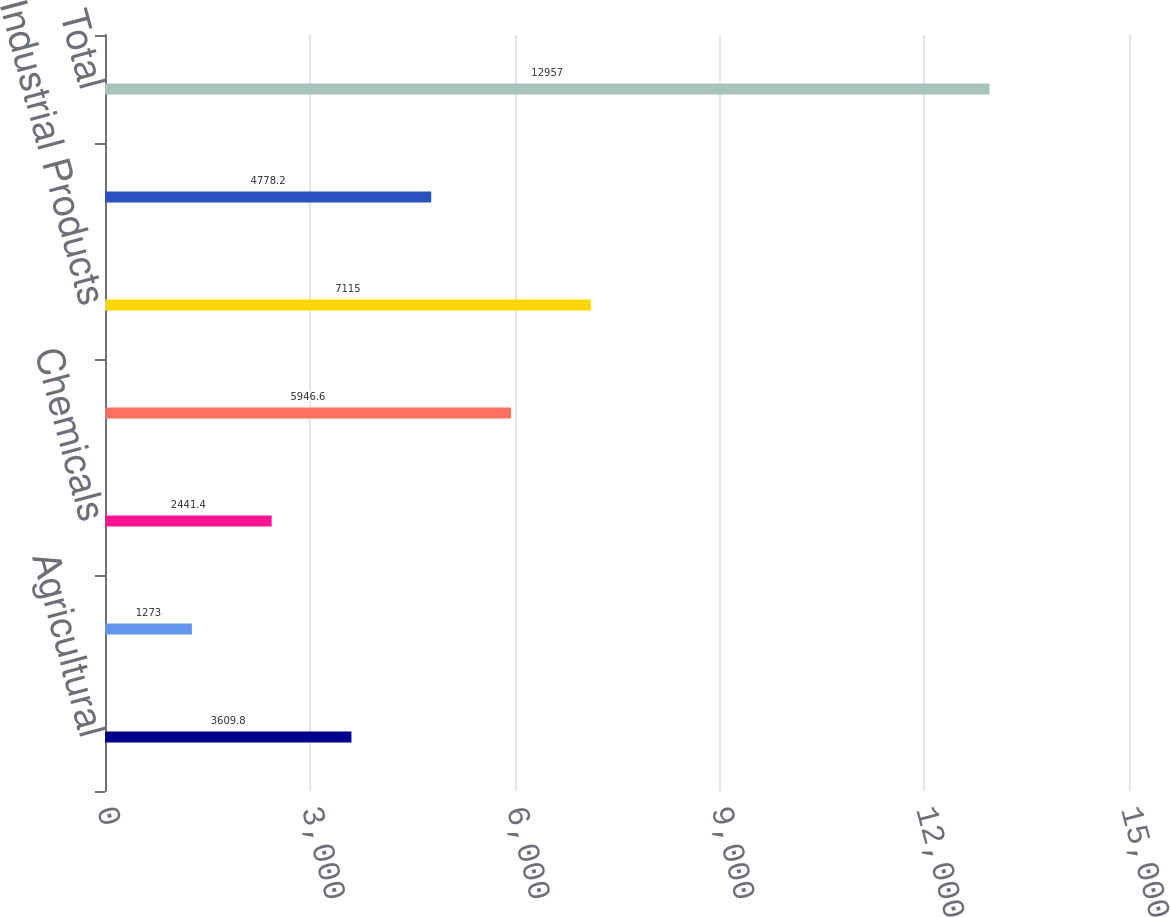<chart> <loc_0><loc_0><loc_500><loc_500><bar_chart><fcel>Agricultural<fcel>Automotive<fcel>Chemicals<fcel>Energy<fcel>Industrial Products<fcel>Intermodal<fcel>Total<nl><fcel>3609.8<fcel>1273<fcel>2441.4<fcel>5946.6<fcel>7115<fcel>4778.2<fcel>12957<nl></chart> 